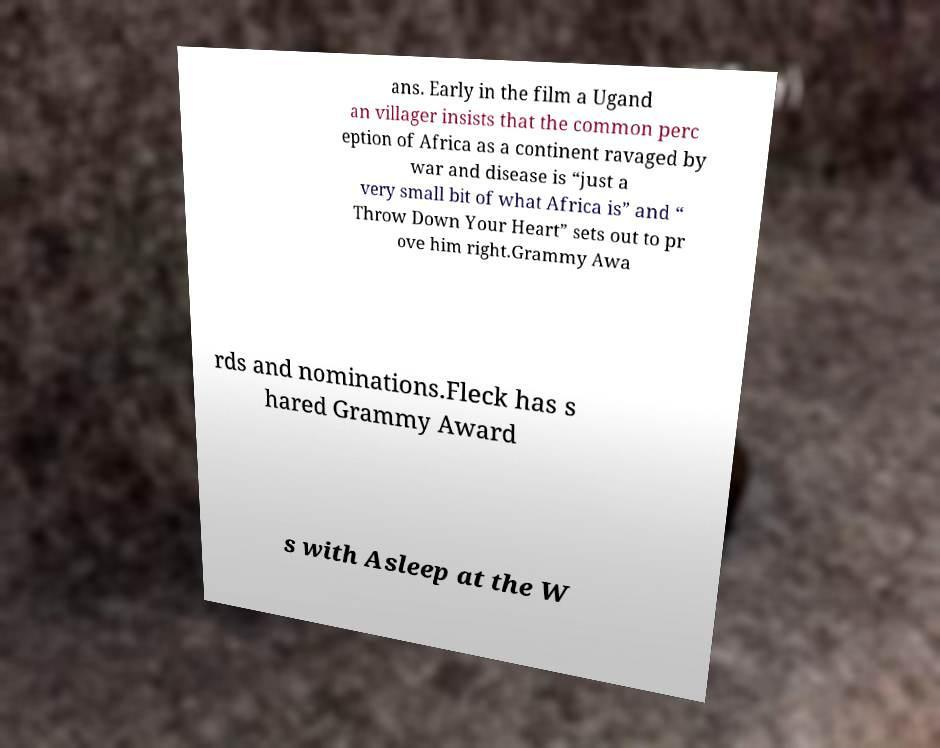What messages or text are displayed in this image? I need them in a readable, typed format. ans. Early in the film a Ugand an villager insists that the common perc eption of Africa as a continent ravaged by war and disease is “just a very small bit of what Africa is” and “ Throw Down Your Heart” sets out to pr ove him right.Grammy Awa rds and nominations.Fleck has s hared Grammy Award s with Asleep at the W 